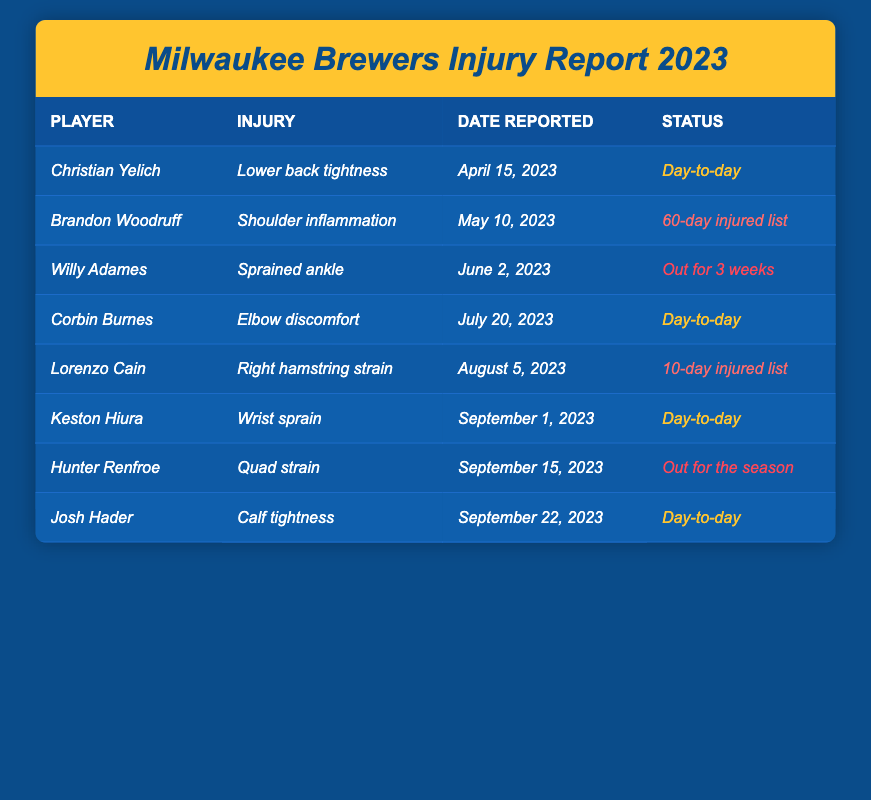What injury did Christian Yelich sustain? The table clearly states that Christian Yelich's injury is "Lower back tightness."
Answer: Lower back tightness When was Brandon Woodruff's injury reported? Referring to the table, Brandon Woodruff's injury was reported on "May 10, 2023."
Answer: May 10, 2023 How many players are currently on the Day-to-Day status? There are 4 players with the status listed as Day-to-Day: Christian Yelich, Corbin Burnes, Keston Hiura, and Josh Hader.
Answer: 4 Is there any player listed as being out for the season? According to the table, Hunter Renfroe is noted as being "Out for the season."
Answer: Yes Which player reported an injury due to a sprain? The table shows that Willy Adames has an injury classified as a "Sprained ankle."
Answer: Willy Adames What is the common type of injury reported in April and July? The common type of injury in April (Christian Yelich: Lower back tightness) and July (Corbin Burnes: Elbow discomfort) is that both are classified as "Day-to-day."
Answer: Day-to-day What percentage of players are listed as injured for more than two weeks? Out of the 8 players, 3 are listed as injured for more than two weeks (Brandon Woodruff, Willy Adames, Hunter Renfroe), which is (3/8)*100 = 37.5%.
Answer: 37.5% What is the total number of players categorized as being on the injured list? The table lists 2 players on the injured list (Brandon Woodruff and Lorenzo Cain with the 10-day injured list), resulting in 2.
Answer: 2 Which player has the longest recovery time reported? The longest recovery time is for Willy Adames, who is "Out for 3 weeks." This is the longest duration compared to others mentioned.
Answer: Willy Adames Does any player have a calf-related injury? Yes, the table shows that Josh Hader has "Calf tightness."
Answer: Yes 